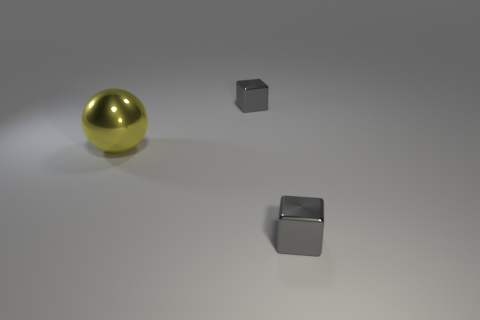Are there an equal number of yellow things that are behind the yellow metallic object and small gray metallic balls?
Offer a very short reply. Yes. How many gray objects are the same size as the yellow ball?
Offer a very short reply. 0. Are there any yellow blocks?
Your answer should be compact. No. There is a shiny thing in front of the sphere; is it the same shape as the tiny gray metal object behind the yellow metal ball?
Ensure brevity in your answer.  Yes. What number of small objects are gray objects or red rubber objects?
Your answer should be compact. 2. The big metal object is what color?
Ensure brevity in your answer.  Yellow. How many objects are either shiny balls or gray shiny objects?
Ensure brevity in your answer.  3. Is there anything else that is the same material as the big yellow ball?
Offer a terse response. Yes. Is the number of large yellow shiny balls that are behind the yellow metallic ball less than the number of large yellow rubber balls?
Provide a short and direct response. No. Is there anything else that is the same color as the shiny sphere?
Your answer should be compact. No. 